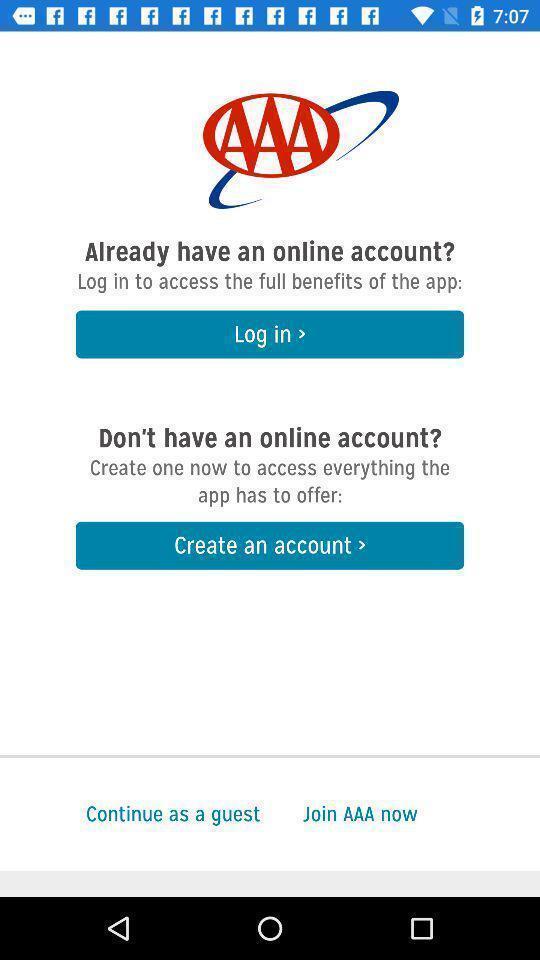Describe the visual elements of this screenshot. Screen shows login details. 